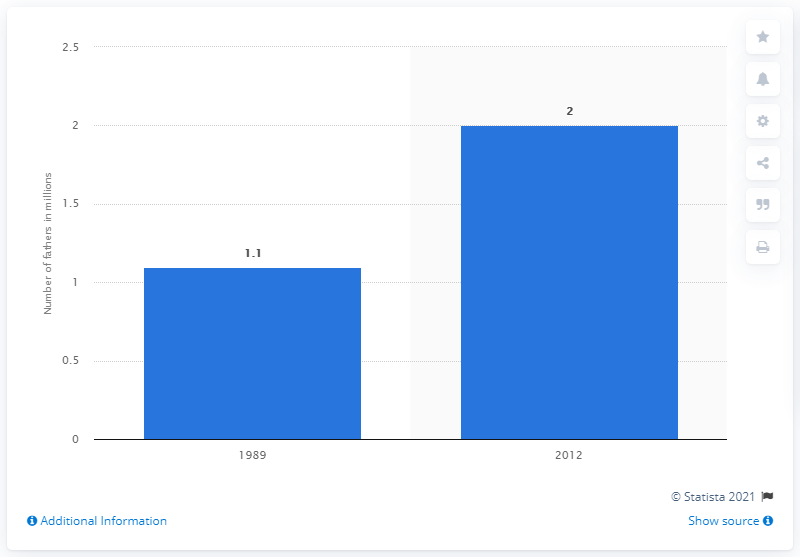Give some essential details in this illustration. According to data from 2012, there were approximately 2 stay-at-home dads. 